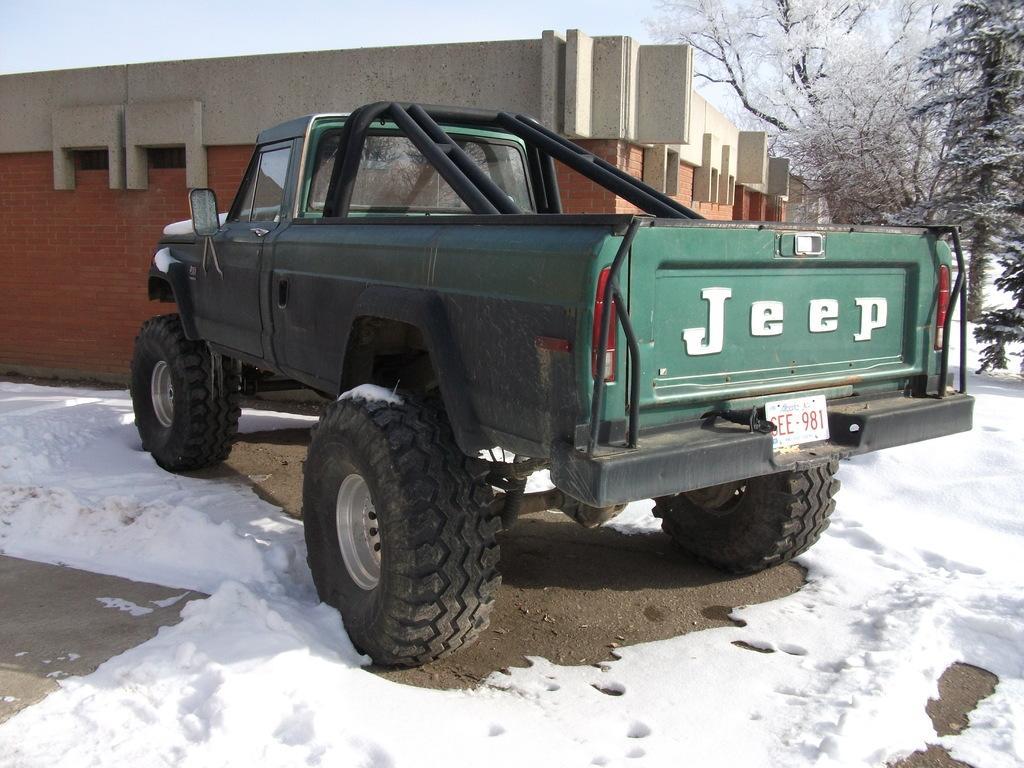Could you give a brief overview of what you see in this image? In this image we can see a jeep on the road and the road is fully covered with the snow. We can also see the building, trees and also the sky. 